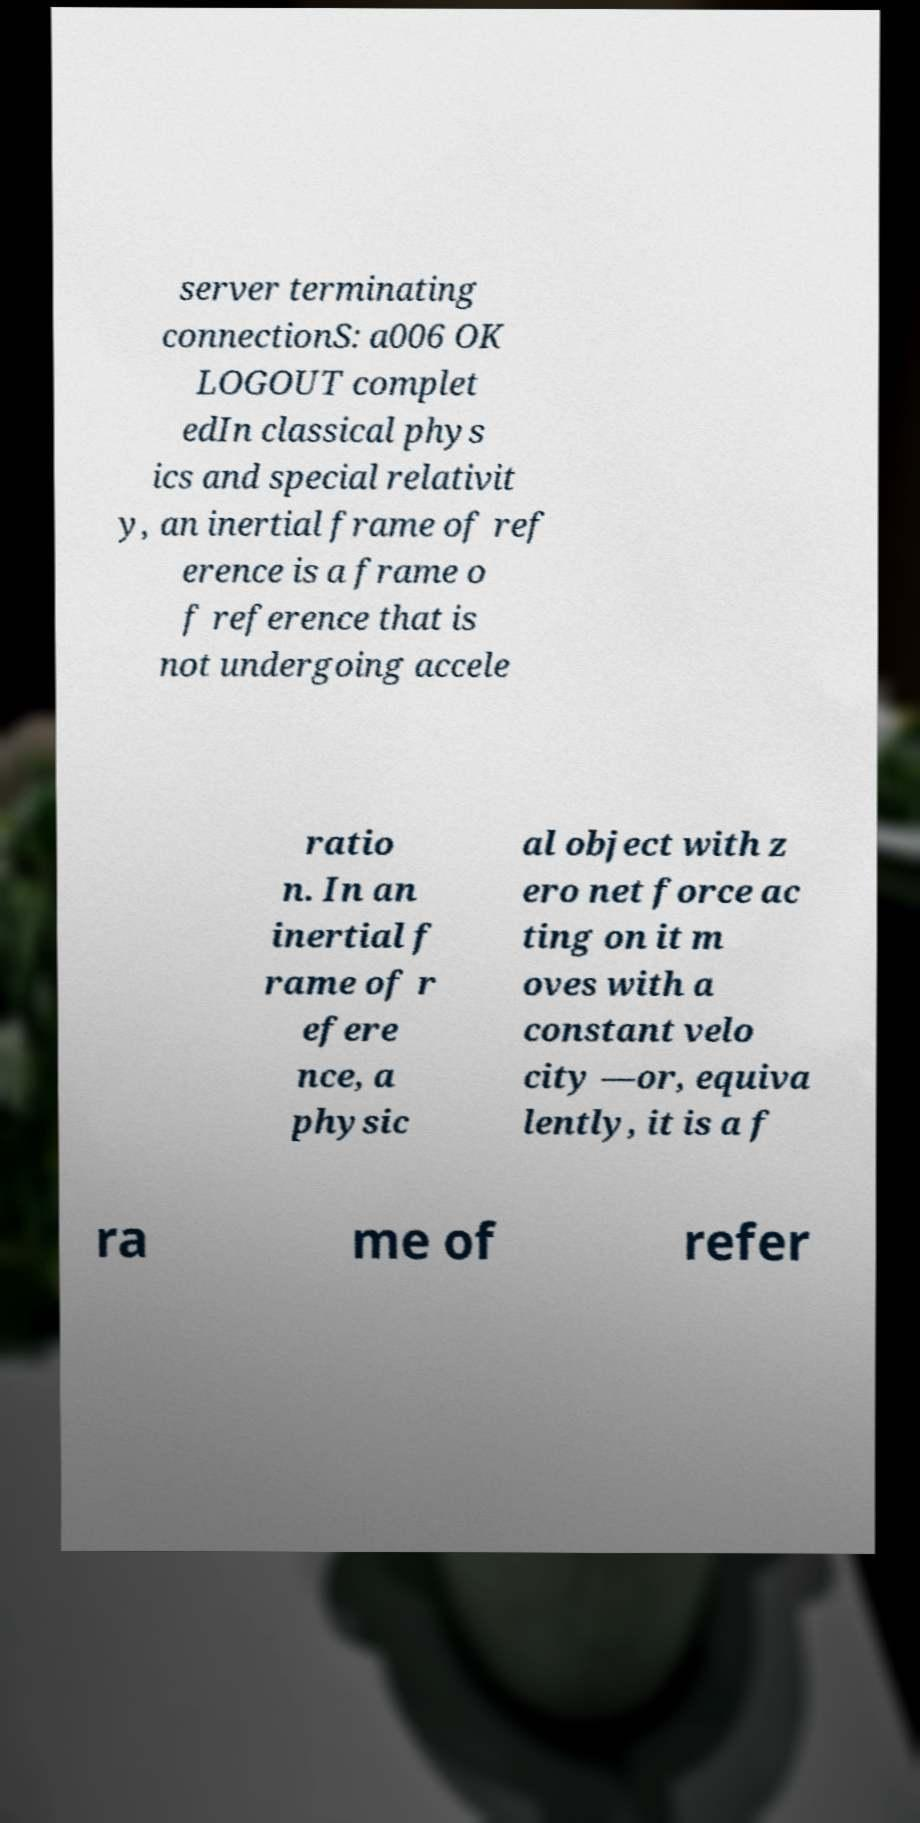There's text embedded in this image that I need extracted. Can you transcribe it verbatim? server terminating connectionS: a006 OK LOGOUT complet edIn classical phys ics and special relativit y, an inertial frame of ref erence is a frame o f reference that is not undergoing accele ratio n. In an inertial f rame of r efere nce, a physic al object with z ero net force ac ting on it m oves with a constant velo city —or, equiva lently, it is a f ra me of refer 